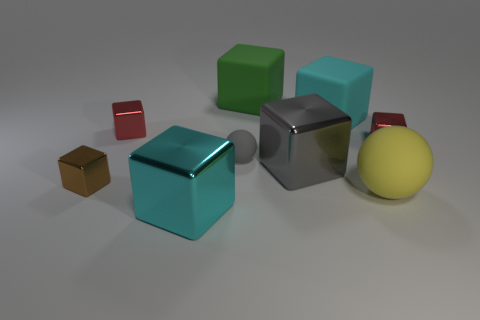Subtract all brown blocks. How many blocks are left? 6 Subtract all big green cubes. How many cubes are left? 6 Subtract all brown cubes. Subtract all green balls. How many cubes are left? 6 Add 1 blocks. How many objects exist? 10 Subtract 0 blue cylinders. How many objects are left? 9 Subtract all spheres. How many objects are left? 7 Subtract all gray things. Subtract all big cyan cubes. How many objects are left? 5 Add 4 cyan cubes. How many cyan cubes are left? 6 Add 5 gray shiny blocks. How many gray shiny blocks exist? 6 